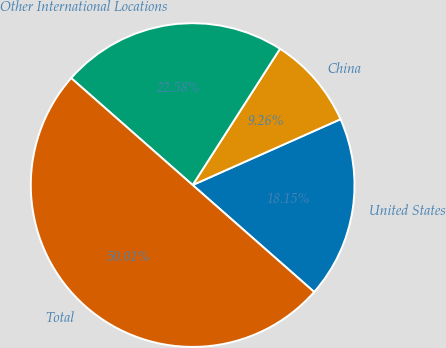Convert chart to OTSL. <chart><loc_0><loc_0><loc_500><loc_500><pie_chart><fcel>United States<fcel>China<fcel>Other International Locations<fcel>Total<nl><fcel>18.15%<fcel>9.26%<fcel>22.58%<fcel>50.0%<nl></chart> 